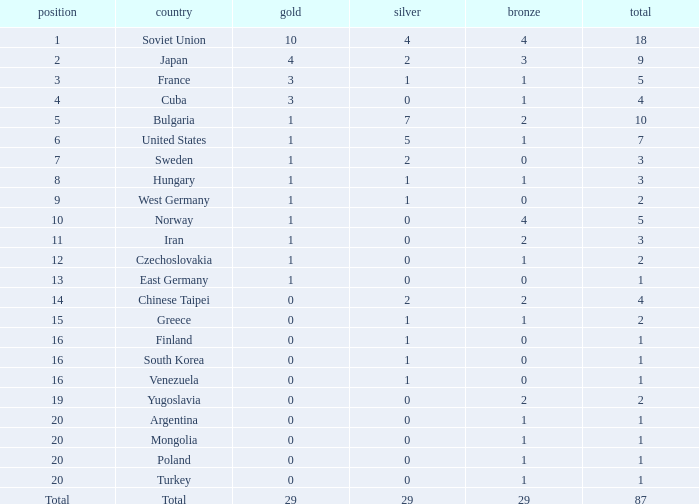Which rank has 1 silver medal and more than 1 gold medal? 3.0. 